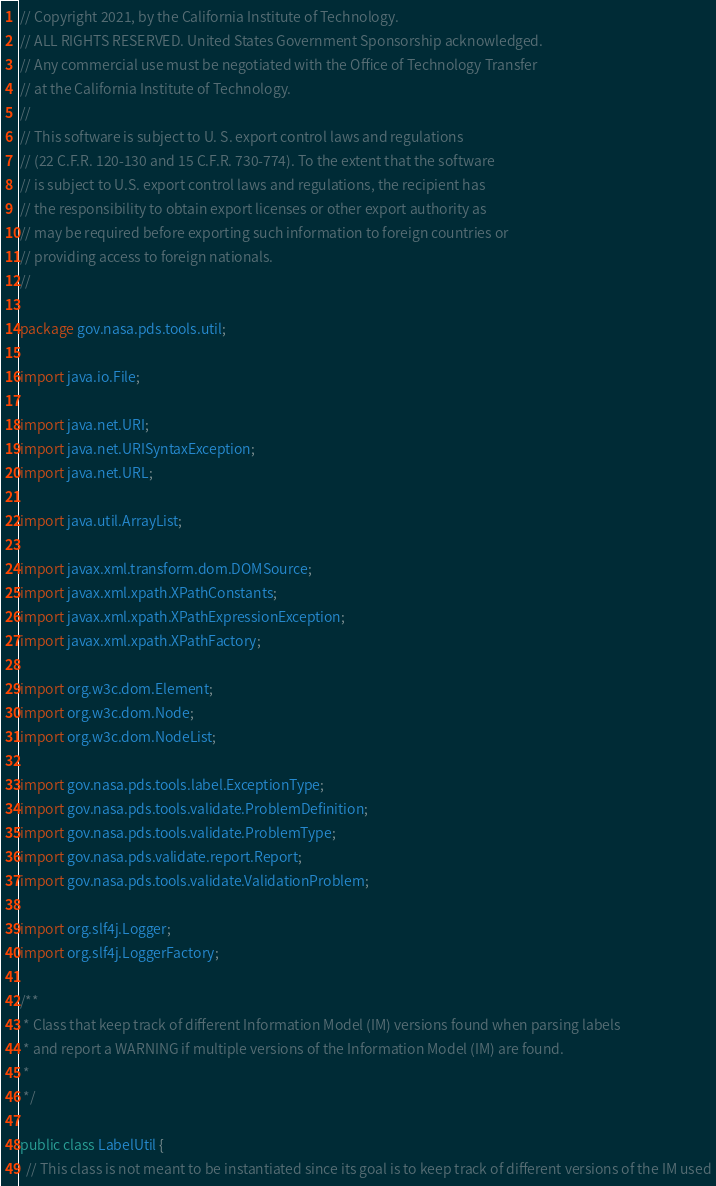<code> <loc_0><loc_0><loc_500><loc_500><_Java_>// Copyright 2021, by the California Institute of Technology.
// ALL RIGHTS RESERVED. United States Government Sponsorship acknowledged.
// Any commercial use must be negotiated with the Office of Technology Transfer
// at the California Institute of Technology.
//
// This software is subject to U. S. export control laws and regulations
// (22 C.F.R. 120-130 and 15 C.F.R. 730-774). To the extent that the software
// is subject to U.S. export control laws and regulations, the recipient has
// the responsibility to obtain export licenses or other export authority as
// may be required before exporting such information to foreign countries or
// providing access to foreign nationals.
//

package gov.nasa.pds.tools.util;

import java.io.File;

import java.net.URI;
import java.net.URISyntaxException;
import java.net.URL;

import java.util.ArrayList;

import javax.xml.transform.dom.DOMSource;
import javax.xml.xpath.XPathConstants;
import javax.xml.xpath.XPathExpressionException;
import javax.xml.xpath.XPathFactory;

import org.w3c.dom.Element;
import org.w3c.dom.Node;
import org.w3c.dom.NodeList;

import gov.nasa.pds.tools.label.ExceptionType;
import gov.nasa.pds.tools.validate.ProblemDefinition;
import gov.nasa.pds.tools.validate.ProblemType;
import gov.nasa.pds.validate.report.Report;
import gov.nasa.pds.tools.validate.ValidationProblem;

import org.slf4j.Logger;
import org.slf4j.LoggerFactory;

/**
 * Class that keep track of different Information Model (IM) versions found when parsing labels
 * and report a WARNING if multiple versions of the Information Model (IM) are found.
 * 
 */

public class LabelUtil {
  // This class is not meant to be instantiated since its goal is to keep track of different versions of the IM used</code> 